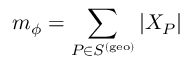Convert formula to latex. <formula><loc_0><loc_0><loc_500><loc_500>m _ { \phi } = \sum _ { P \in S ^ { ( g e o ) } } | X _ { P } |</formula> 